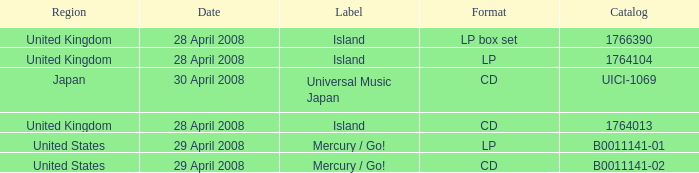What is the Region of the 1766390 Catalog? United Kingdom. 